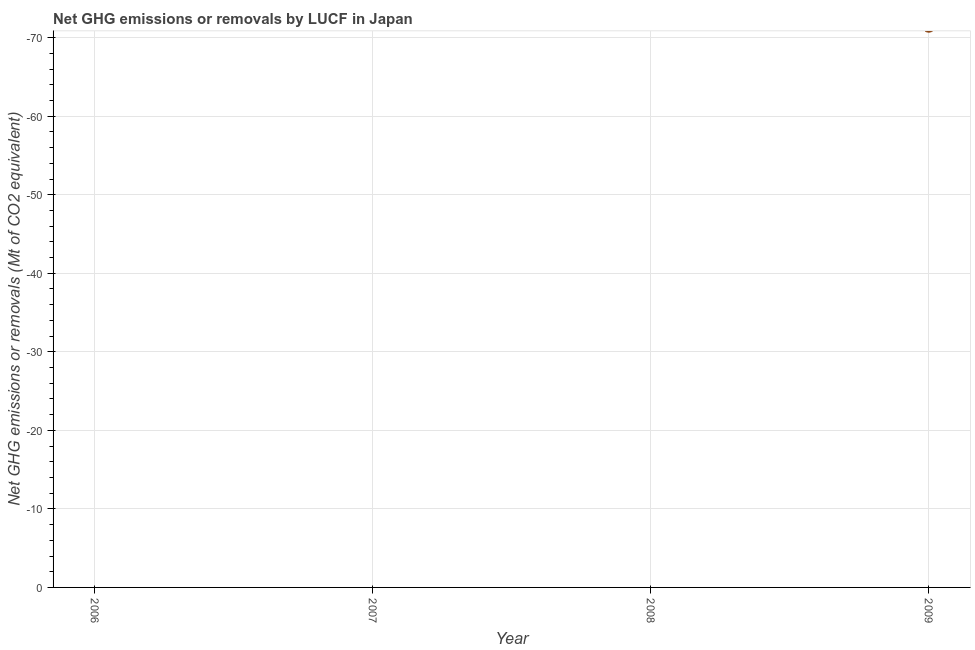What is the sum of the ghg net emissions or removals?
Keep it short and to the point. 0. In how many years, is the ghg net emissions or removals greater than -4 Mt?
Keep it short and to the point. 0. In how many years, is the ghg net emissions or removals greater than the average ghg net emissions or removals taken over all years?
Provide a short and direct response. 0. How many dotlines are there?
Make the answer very short. 0. Does the graph contain any zero values?
Your response must be concise. Yes. What is the title of the graph?
Your answer should be compact. Net GHG emissions or removals by LUCF in Japan. What is the label or title of the Y-axis?
Provide a succinct answer. Net GHG emissions or removals (Mt of CO2 equivalent). What is the Net GHG emissions or removals (Mt of CO2 equivalent) in 2006?
Provide a succinct answer. 0. What is the Net GHG emissions or removals (Mt of CO2 equivalent) in 2007?
Your answer should be compact. 0. What is the Net GHG emissions or removals (Mt of CO2 equivalent) in 2008?
Provide a short and direct response. 0. 